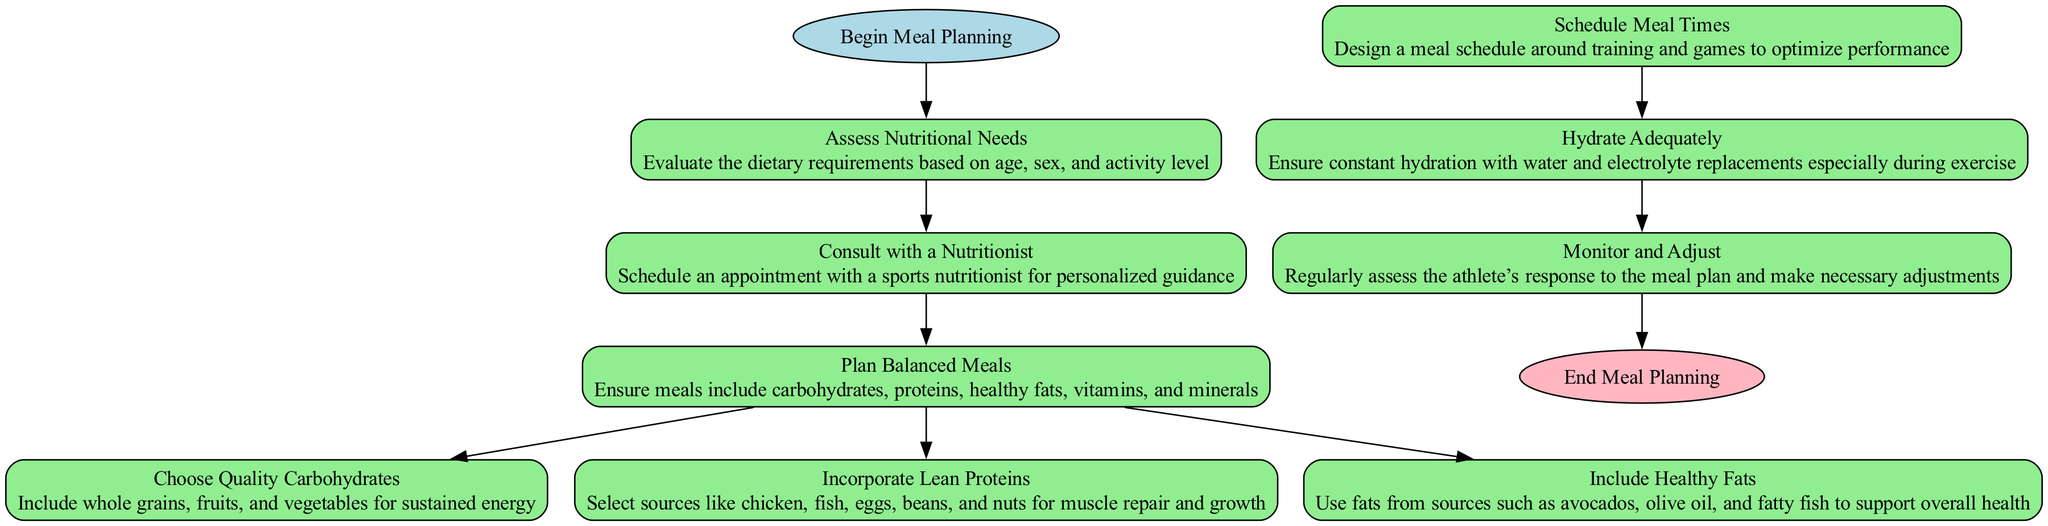What is the first step in meal planning? The first step in meal planning, as shown in the diagram, is "Assess Nutritional Needs." It is the initial action that begins the flow of the meal planning process.
Answer: Assess Nutritional Needs How many elements are there in the flow chart? By counting each unique element represented in the diagram, there are a total of 9 elements, including the starting point and the end point.
Answer: 9 What type of node follows "Consult with a Nutritionist"? The node that follows "Consult with a Nutritionist" is "Plan Balanced Meals," which indicates the next action after the consultation.
Answer: Plan Balanced Meals What are the three types of food sources suggested after planning balanced meals? The three types of food sources suggested are "Quality Carbohydrates," "Lean Proteins," and "Healthy Fats," as all three are necessary components of balanced meals.
Answer: Quality Carbohydrates, Lean Proteins, Healthy Fats What happens after incorporating lean proteins? After "Incorporate Lean Proteins," the flow of the diagram ends for that specific action as there are no further steps indicated branching out from that node.
Answer: End of flow for that action Which node emphasizes the importance of hydration? The node that emphasizes the importance of hydration is "Hydrate Adequately," which follows the scheduling of meal times in the meal planning process.
Answer: Hydrate Adequately What is the last action in the flow chart before concluding the meal planning process? The last action in the flow chart is "Monitor and Adjust," as it comes right before reaching the conclusion of meal planning.
Answer: Monitor and Adjust How does one progress from scheduling meal times? From "Schedule Meal Times," the next step progresses to "Hydrate Adequately," indicating that hydration is an essential factor to consider after meal scheduling.
Answer: Hydrate Adequately What is the primary focus of the "Assess Nutritional Needs" node? The primary focus of the "Assess Nutritional Needs" node is to evaluate dietary requirements based on age, sex, and activity level, laying the groundwork for the meal plan.
Answer: Evaluate dietary requirements based on age, sex, and activity level 